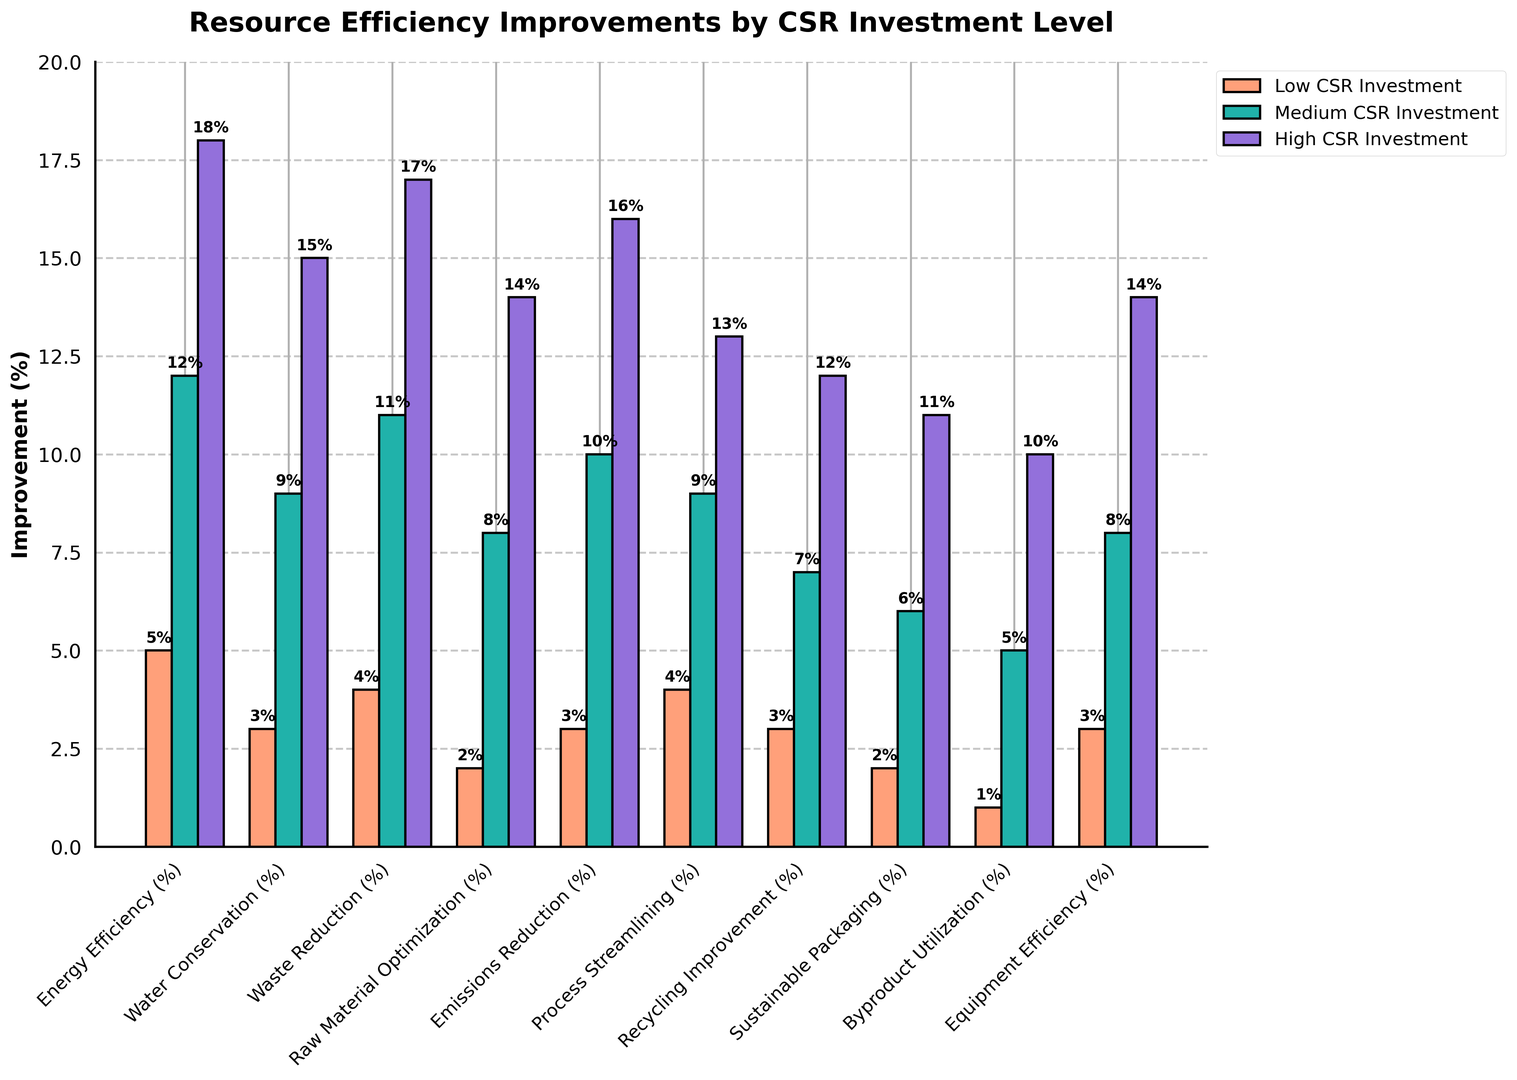Which resource efficiency type shows the highest improvement for high CSR investment? The purple bars represent high CSR investment. By examining the heights of these bars, the Energy Efficiency bar is the highest, which indicates it has the highest improvement.
Answer: Energy Efficiency What is the difference in emissions reduction percentage between low and high CSR investment? The red bar for low CSR investment in emissions reduction is at 3%, and the purple bar for high CSR investment is at 16%. The difference is 16 - 3 = 13%.
Answer: 13% How much higher is the water conservation improvement for medium CSR investment compared to low CSR investment? The green bar for medium CSR investment in water conservation is at 9%, whereas the red bar for low CSR investment is at 3%. The difference is 9 - 3 = 6%.
Answer: 6% Which CSR investment level has the lowest improvement in energy efficiency? By comparing the heights of the bars representing energy efficiency, the red bar (low CSR investment) is the shortest, indicating the lowest improvement.
Answer: Low CSR Investment What is the average improvement percentage for recycling improvement across all CSR investment levels? The red bar for low CSR investment in recycling improvement is 3%, the green bar for medium CSR is 7%, and the purple bar for high CSR is 12%. The average is (3 + 7 + 12) / 3 = 22 / 3 ≈ 7.33%.
Answer: 7.33% Which attribute has a higher improvement percentage from low to high CSR investment: sustainable packaging or byproduct utilization? The red bar for sustainable packaging shows 2% improvement for low CSR investment while the purple bar shows 11% for high CSR, a difference of 11 - 2 = 9%. For byproduct utilization, the red bar shows 1% for low CSR and the purple bar shows 10% for high CSR, a difference of 10 - 1 = 9%. Both attributes have the same improvement percentage increase.
Answer: Same How much higher is the raw material optimization improvement for high CSR investment compared to medium CSR investment? The green bar for medium CSR investment in raw material optimization is at 8%, and the purple bar for high CSR investment is at 14%. The difference is 14 - 8 = 6%.
Answer: 6% What is the total improvement percentage recorded for low CSR investment across all resource efficiency types? Sum up the values from the red bars for each resource efficiency type: 5 + 3 + 4 + 2 + 3 + 4 + 3 + 2 + 1 + 3 = 30%.
Answer: 30% Which color represents medium CSR investment in the figure? The figure legend indicates that the bars representing medium CSR investment are green.
Answer: Green What is the improvement difference between process streamlining and equipment efficiency for medium CSR investment? The green bar for medium CSR investment in process streamlining shows 9%, and the green bar for medium CSR investment in equipment efficiency shows 8%. The difference is 9 - 8 = 1%.
Answer: 1% 